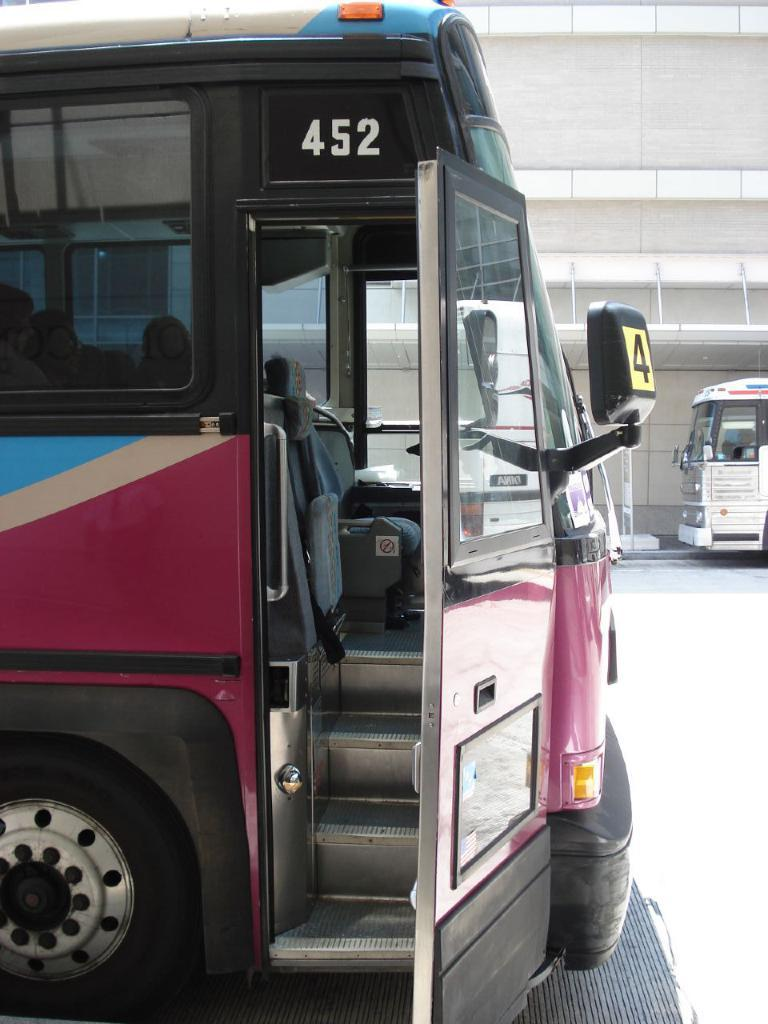<image>
Provide a brief description of the given image. Bus number 452 sitting at a bus depot. 